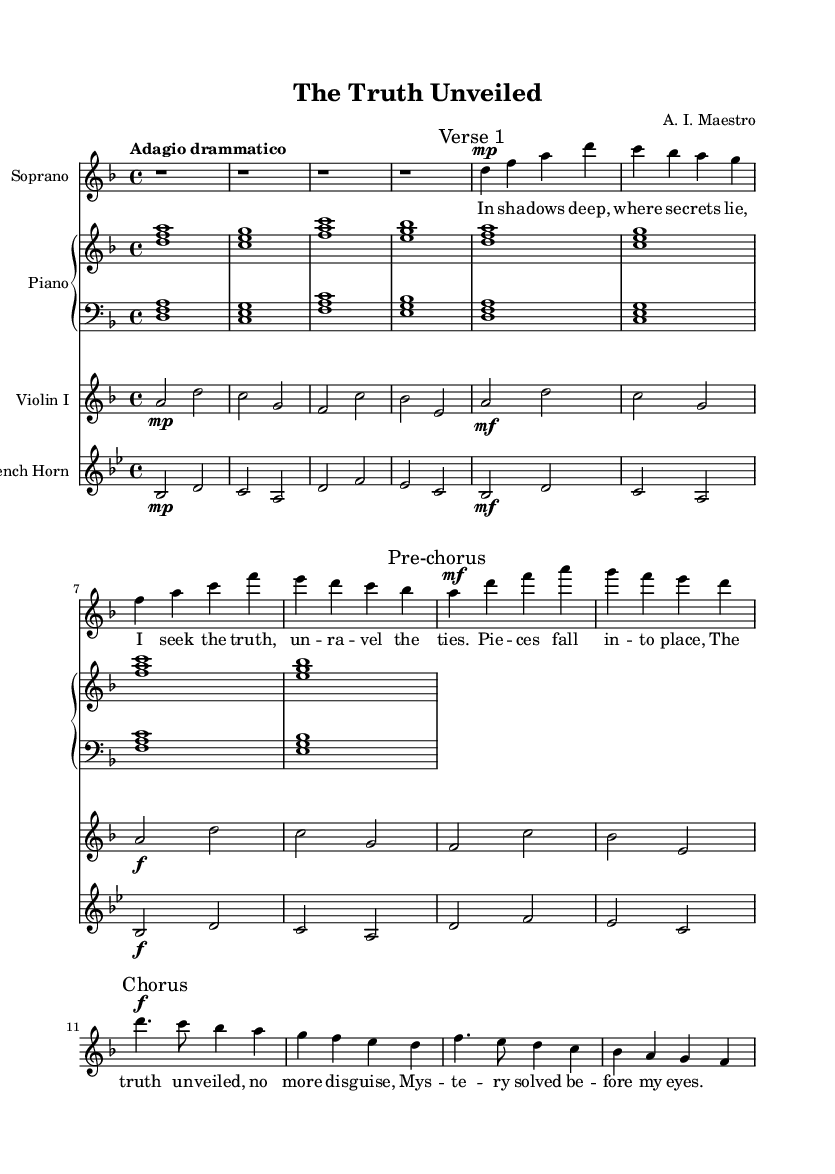What is the key signature of this music? The key signature is indicated at the beginning of the score, where we see two flats, which corresponds to the key of D minor.
Answer: D minor What is the time signature of this piece? The time signature is shown at the beginning of the score, displayed as a fraction, and indicates that there are 4 beats per measure, which is represented as 4/4.
Answer: 4/4 What is the tempo marking of the score? The tempo marking, presented above the staff, is "Adagio drammatico," which suggests a slow and dramatic pace for the performance.
Answer: Adagio drammatico What is the dynamic marking at the beginning of the chorus? In the chorus section, the dynamic marking is shown as a forte (f), which indicates that this part should be played loudly compared to other sections.
Answer: forte How many measures are in the chorus section? By counting the measures within the chorus section, which is marked accordingly, we can see there are four measures.
Answer: four What is the mood conveyed by the lyrics in the first verse? The lyrics express a sense of seeking and unveiling hidden truths, indicating a mood of mystery and drama as they describe shadows and secrets.
Answer: mystery Which instrument is indicated to play a solo in this score? The soprano part is highlighted as the main voice in this score, indicating that it has the leading role in the composition.
Answer: soprano 